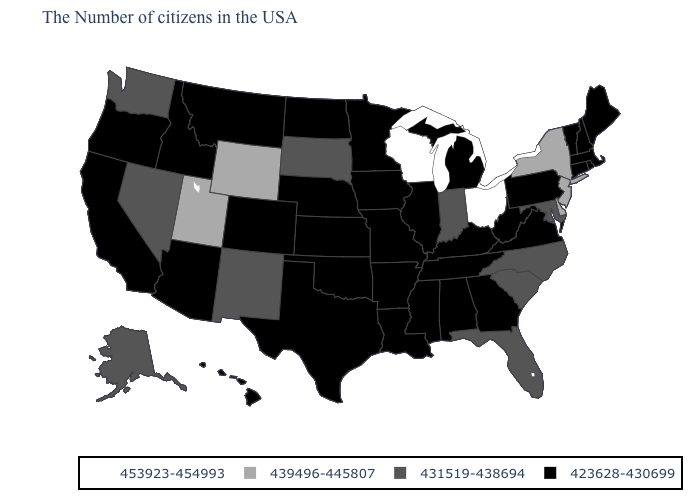What is the value of Virginia?
Be succinct. 423628-430699. Among the states that border Indiana , does Michigan have the lowest value?
Write a very short answer. Yes. Name the states that have a value in the range 423628-430699?
Short answer required. Maine, Massachusetts, Rhode Island, New Hampshire, Vermont, Connecticut, Pennsylvania, Virginia, West Virginia, Georgia, Michigan, Kentucky, Alabama, Tennessee, Illinois, Mississippi, Louisiana, Missouri, Arkansas, Minnesota, Iowa, Kansas, Nebraska, Oklahoma, Texas, North Dakota, Colorado, Montana, Arizona, Idaho, California, Oregon, Hawaii. Does the first symbol in the legend represent the smallest category?
Give a very brief answer. No. What is the value of Illinois?
Quick response, please. 423628-430699. What is the value of Oklahoma?
Write a very short answer. 423628-430699. Name the states that have a value in the range 431519-438694?
Be succinct. Maryland, North Carolina, South Carolina, Florida, Indiana, South Dakota, New Mexico, Nevada, Washington, Alaska. Among the states that border Utah , which have the highest value?
Be succinct. Wyoming. Name the states that have a value in the range 423628-430699?
Short answer required. Maine, Massachusetts, Rhode Island, New Hampshire, Vermont, Connecticut, Pennsylvania, Virginia, West Virginia, Georgia, Michigan, Kentucky, Alabama, Tennessee, Illinois, Mississippi, Louisiana, Missouri, Arkansas, Minnesota, Iowa, Kansas, Nebraska, Oklahoma, Texas, North Dakota, Colorado, Montana, Arizona, Idaho, California, Oregon, Hawaii. Does Iowa have the highest value in the USA?
Write a very short answer. No. Which states have the lowest value in the Northeast?
Quick response, please. Maine, Massachusetts, Rhode Island, New Hampshire, Vermont, Connecticut, Pennsylvania. How many symbols are there in the legend?
Be succinct. 4. Among the states that border California , which have the highest value?
Concise answer only. Nevada. Name the states that have a value in the range 423628-430699?
Concise answer only. Maine, Massachusetts, Rhode Island, New Hampshire, Vermont, Connecticut, Pennsylvania, Virginia, West Virginia, Georgia, Michigan, Kentucky, Alabama, Tennessee, Illinois, Mississippi, Louisiana, Missouri, Arkansas, Minnesota, Iowa, Kansas, Nebraska, Oklahoma, Texas, North Dakota, Colorado, Montana, Arizona, Idaho, California, Oregon, Hawaii. 